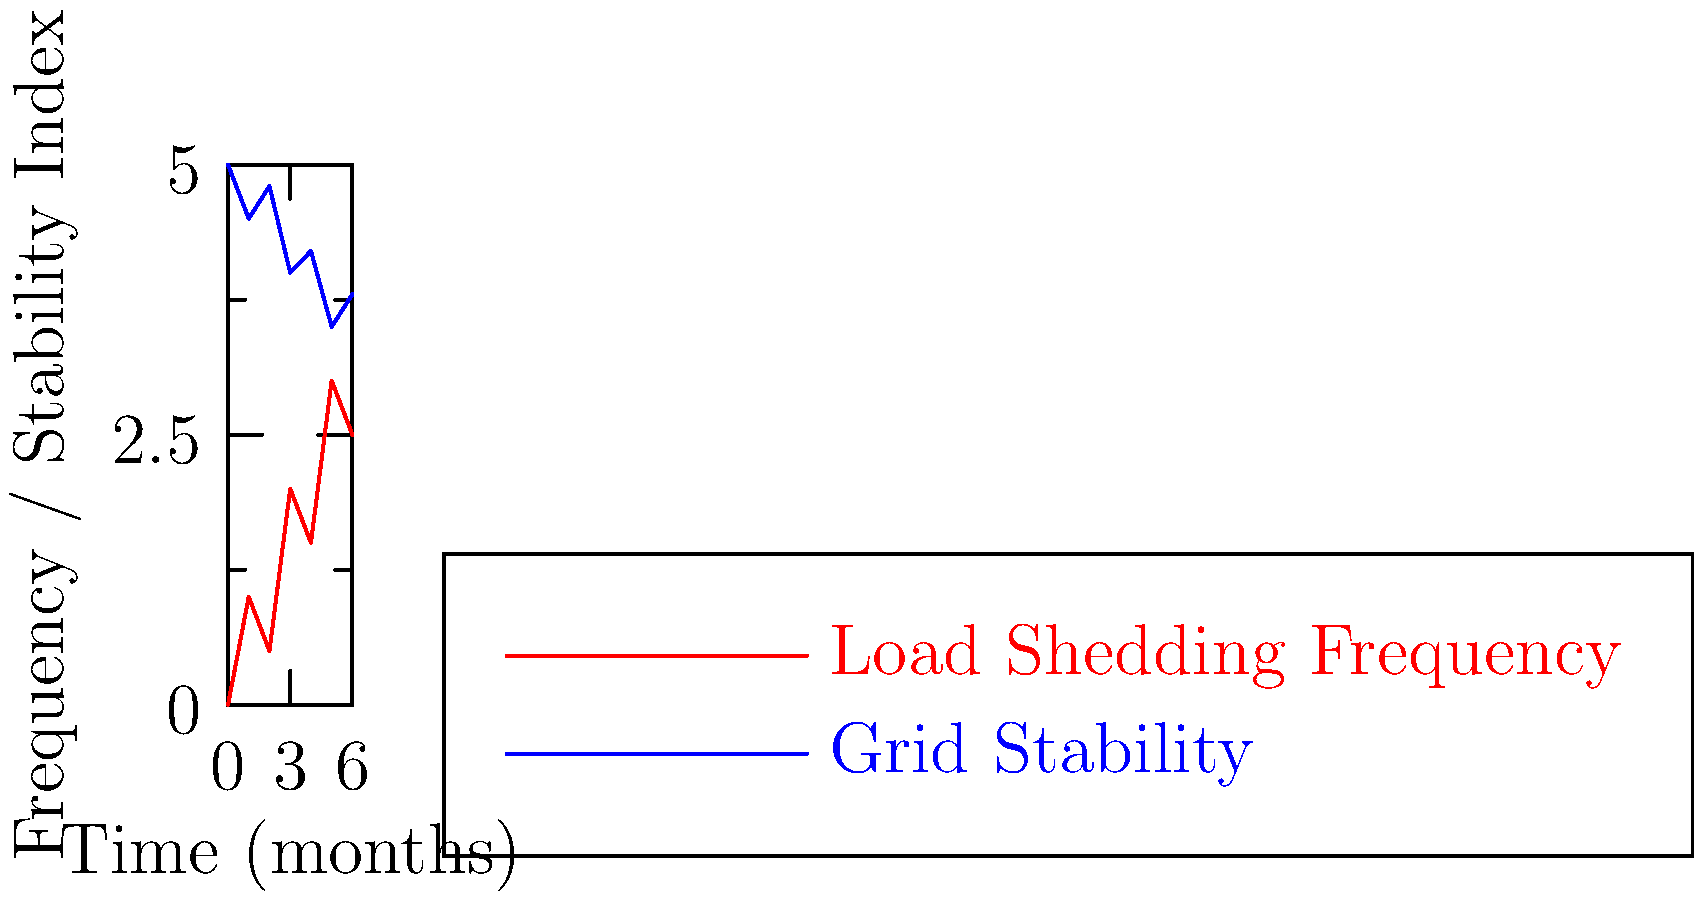Based on the line chart showing the relationship between load shedding frequency and power grid stability over a 6-month period, what can be inferred about the overall trend in South Africa's energy crisis? To analyze the relationship between load shedding frequency and power grid stability:

1. Observe the red line (Load Shedding Frequency):
   - It shows an overall increasing trend over time.
   - There are fluctuations, but the general direction is upward.

2. Observe the blue line (Grid Stability):
   - It shows an overall decreasing trend over time.
   - There are minor fluctuations, but the general direction is downward.

3. Compare the two lines:
   - As load shedding frequency increases, grid stability decreases.
   - This inverse relationship is consistent throughout the 6-month period.

4. Interpret the trends:
   - The increasing frequency of load shedding suggests a worsening energy crisis.
   - The decreasing grid stability indicates a deteriorating power infrastructure.

5. Consider the implications:
   - The inverse relationship suggests that frequent load shedding is negatively impacting the power grid's stability.
   - This could lead to a cycle where instability causes more load shedding, further destabilizing the grid.

6. Draw a conclusion:
   - The overall trend indicates an escalating energy crisis in South Africa, characterized by more frequent load shedding and decreasing grid stability.
Answer: Escalating energy crisis with increasing load shedding and decreasing grid stability. 